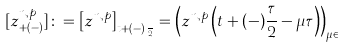<formula> <loc_0><loc_0><loc_500><loc_500>[ z _ { + \left ( - \right ) } ^ { n , p } ] \colon = \left [ z ^ { n , p } \right ] _ { t + ( - ) \frac { \tau } { 2 } } = \left ( z ^ { n , p } \left ( t + ( - ) \frac { \tau } { 2 } - \mu \tau \right ) \right ) _ { \mu \in \mathbb { N } }</formula> 